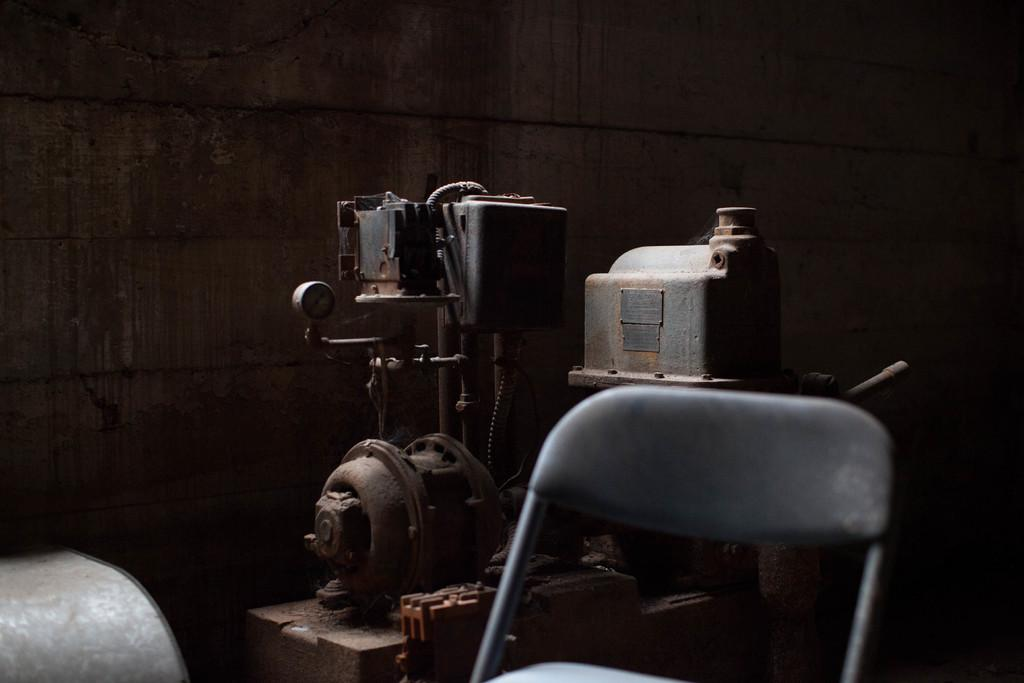What is the main object in the image? There is a machine in the image. What is another object visible in the image? There is a chair in the image. What can be seen in the background of the image? There is a wall in the background of the image. What type of quilt is draped over the machine in the image? There is no quilt present in the image; it only features a machine and a chair in front of a wall. 